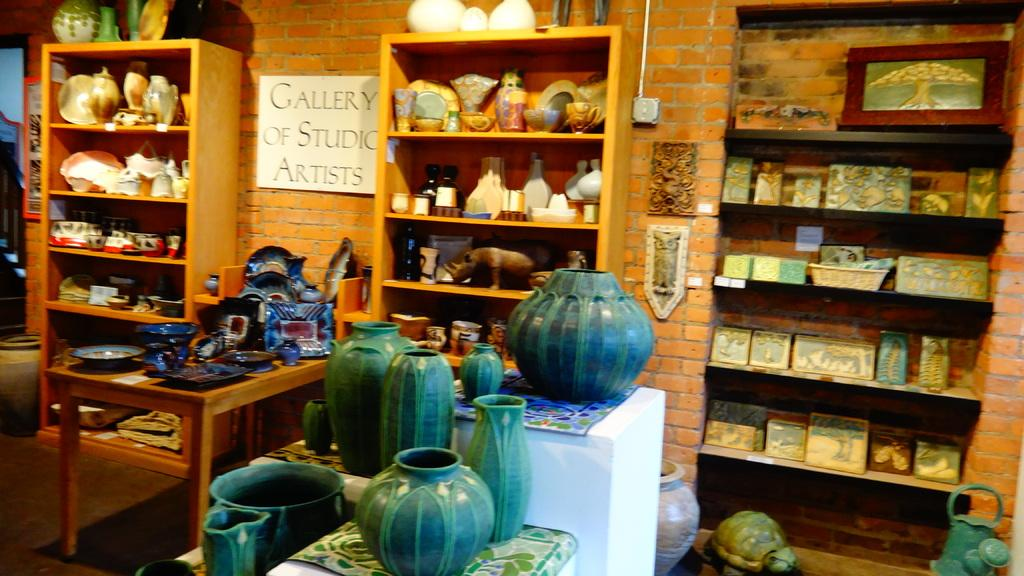Provide a one-sentence caption for the provided image. a shop with ceramics and a sign saying Gallery of Studio Artists. 